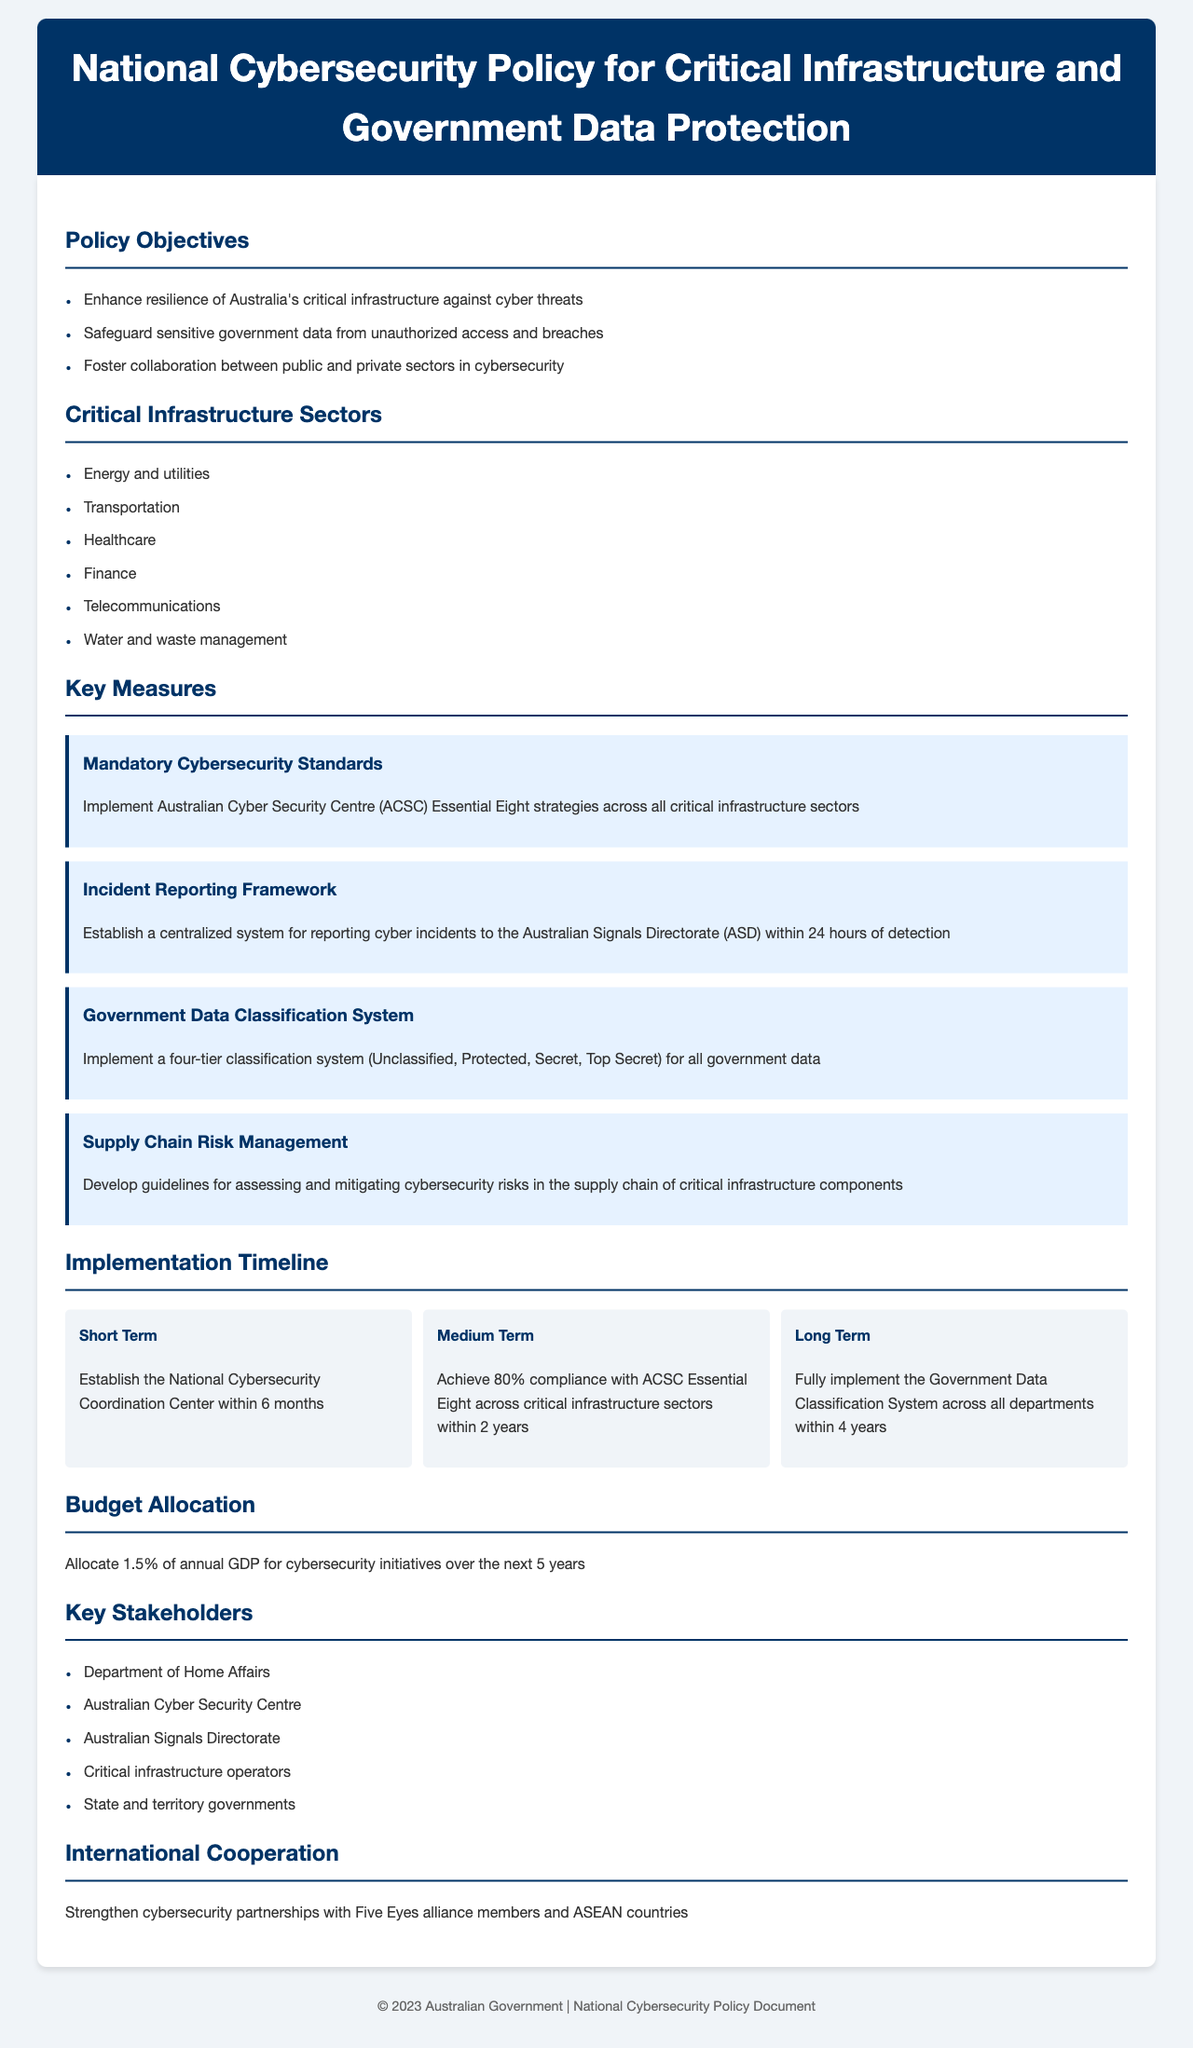What are the three policy objectives? The document lists three policy objectives: enhance resilience of Australia's critical infrastructure, safeguard sensitive government data, and foster collaboration between public and private sectors.
Answer: Enhance resilience, safeguard sensitive government data, foster collaboration What is the first critical infrastructure sector listed? The document enumerates critical infrastructure sectors, with energy and utilities as the first one mentioned.
Answer: Energy and utilities What is the budget allocation percentage for cybersecurity initiatives? The document states that 1.5% of annual GDP is allocated for cybersecurity initiatives over the next 5 years.
Answer: 1.5% What is the timeline for establishing the National Cybersecurity Coordination Center? The document indicates that the establishment of the National Cybersecurity Coordination Center is to be completed within 6 months.
Answer: Within 6 months What is the classification system used for government data? The document mentions a four-tier classification system: Unclassified, Protected, Secret, Top Secret.
Answer: Unclassified, Protected, Secret, Top Secret Which organization is responsible for reporting cyber incidents? According to the document, the centralized system for cyber incidents reporting is established for the Australian Signals Directorate.
Answer: Australian Signals Directorate What is the compliance target for ACSC Essential Eight in the medium term? The document specifies that the target is to achieve 80% compliance with ACSC Essential Eight across critical infrastructure sectors within 2 years.
Answer: 80% What international partnerships are mentioned in the policy? The document refers to strengthening cybersecurity partnerships with Five Eyes alliance members and ASEAN countries.
Answer: Five Eyes alliance members and ASEAN countries 